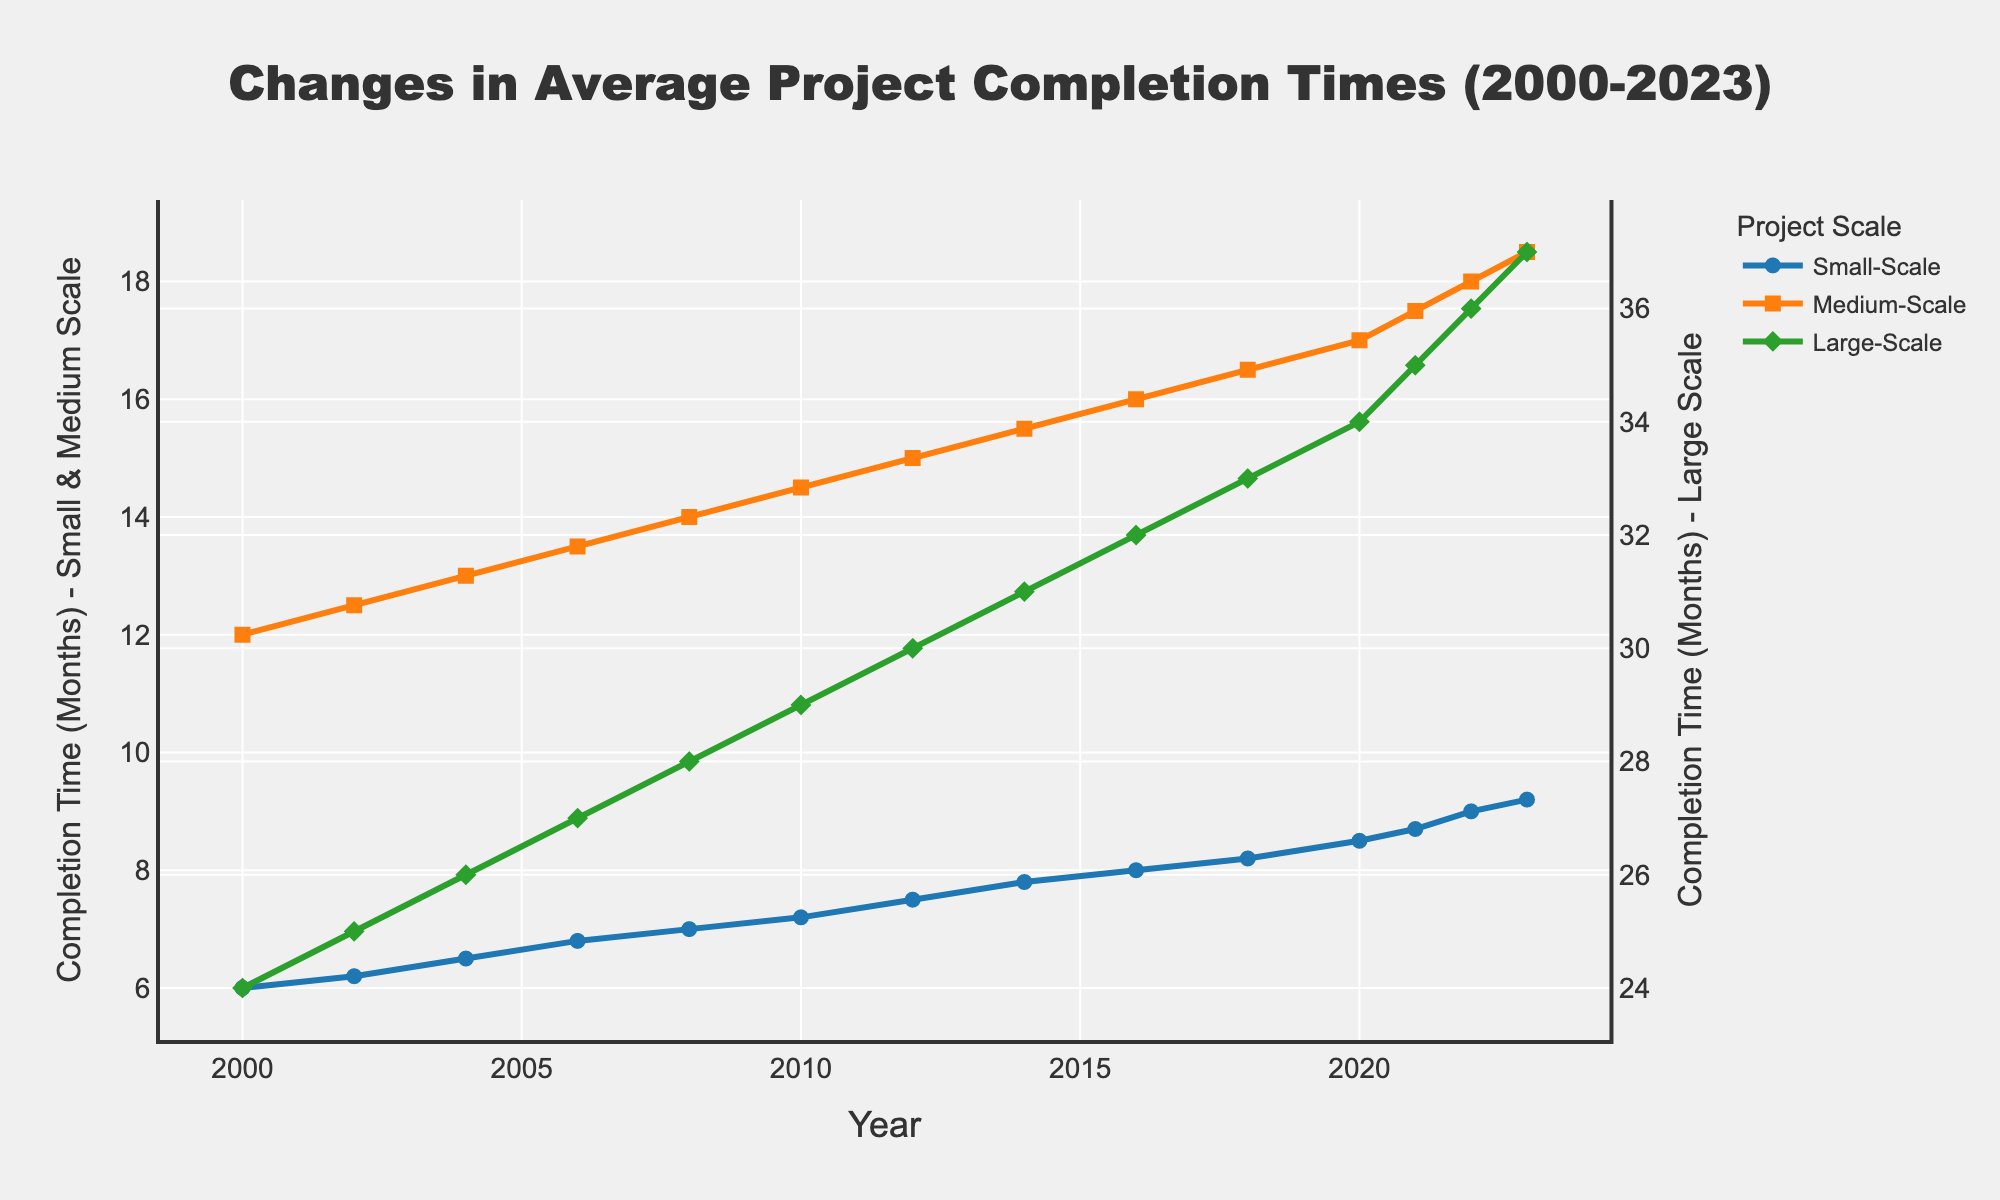What is the completion time for small-scale projects in 2020? Locate the small-scale project line (blue) and find the data point above the year 2020.
Answer: 8.5 months How much did the completion time for large-scale projects increase from 2000 to 2023? Check the large-scale project line (green) and identify the completion times for 2000 (24 months) and 2023 (37 months). Compute their difference, 37 - 24.
Answer: 13 months Which scale of projects saw the greatest increase in completion time over the years? Compare the starting and ending points of the lines for small-scale (6 to 9.2), medium-scale (12 to 18.5), and large-scale (24 to 37). Calculate the differences: small (3.2 months), medium (6.5 months), large (13 months).
Answer: Large-scale In 2012, how does the completion time for medium-scale projects compare to small-scale projects? Locate the points on the medium-scale (orange) and small-scale (blue) lines for 2012. Medium-scale is at 15 months, and small-scale is 7.5 months. Compare these values, 15 > 7.5.
Answer: Medium-scale is higher What is the average completion time for medium-scale projects between 2000 and 2023? Add completion times for medium-scale projects from each year in the dataset (12, 12.5, 13, 13.5, 14, 14.5, 15, 15.5, 16, 16.5, 17, 17.5, 18, 18.5). Divide the total sum (215) by the number of years (14).
Answer: 15.36 months When did small-scale projects start taking longer than 8 months to complete? On the small-scale line (blue), look for the first data point above 8 months. It occurs in 2016.
Answer: 2016 What's the difference in completion time between large-scale and medium-scale projects in 2023? Find the values for large-scale (37 months) and medium-scale (18.5 months) in 2023. Compute their difference, 37 - 18.5.
Answer: 18.5 months During which year did medium-scale projects reach a completion time of 15 months? Locate the data point on the medium-scale line (orange) where it intersects 15 months.
Answer: 2012 